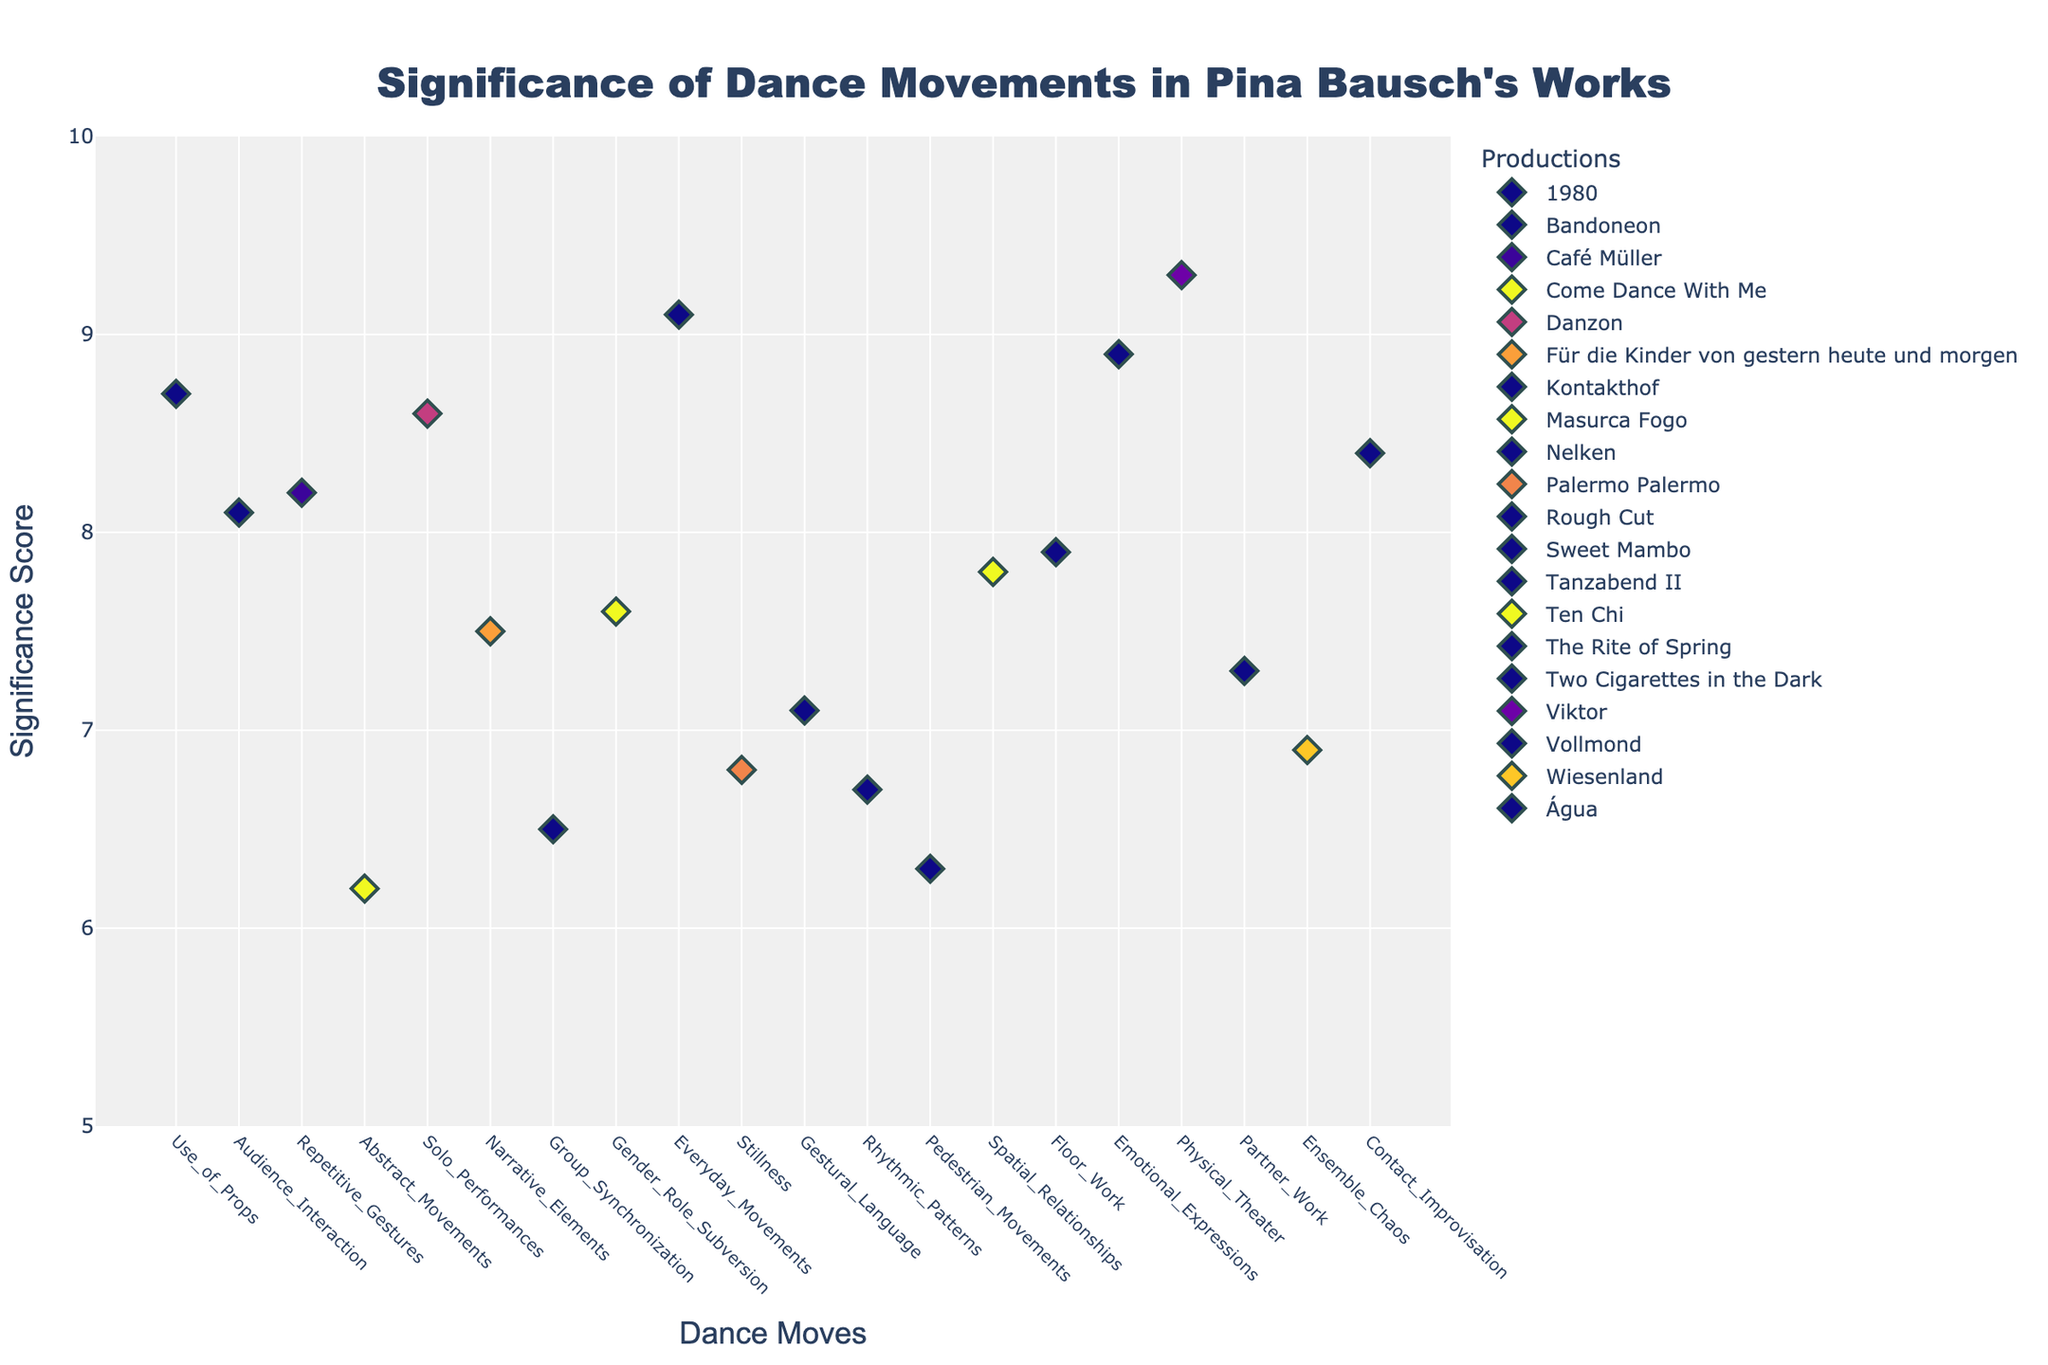What is the title of the figure? The title of the figure is usually located at the top and stands out due to its larger and bold font size. Here, it is "Significance of Dance Movements in Pina Bausch's Works".
Answer: Significance of Dance Movements in Pina Bausch's Works What are the x and y axes labeled as? The x-axis is labeled as "Dance Moves", and the y-axis is labeled as "Significance Score". These labels clearly indicate the dimensions along which the data points are plotted.
Answer: Dance Moves, Significance Score Which dance move has the highest significance score, and what is that score? By observing the y-axis and identifying the highest marker on the plot, we see that "Physical Theater" has the highest significance score of 9.3 in the production "Viktor".
Answer: Physical Theater, 9.3 What is the significance score of "Everyday Movements" and which production is it associated with? Locate "Everyday Movements" on the x-axis and read off its y-value. It is associated with the "Nelken" production and has a significance score of 9.1.
Answer: 9.1, Nelken How many dance moves have a significance score of 8.0 or higher? Count the markers on the plot with y-values of 8.0 or higher. These include "Repetitive Gestures," "Everyday Movements," "Use of Props," "Emotional Expressions," "Contact Improvisation," "Solo Performances," "Audience Interaction," and "Physical Theater", totaling 8.
Answer: 8 Which production has the most number of dance moves scored, and how many does it have? Each unique production name is associated with dance moves on the x-axis. By counting the occurrences, it becomes clear that each production has only one associated dance move.
Answer: Each production has 1 dance move What dance move has the lowest significance score, and which production does it belong to? Find the lowest point on the y-axis and check the x-axis to identify the dance move and the hover text for the production. It’s "Abstract Movements" belonging to "Come Dance With Me" with a score of 6.2.
Answer: Abstract Movements, Come Dance With Me Does "Group Synchronization" in "Kontakthof" or "Partner Work" in "Vollmond" have a higher significance score? Compare the y-values of "Group Synchronization" and "Partner Work". "Partner Work" in "Vollmond" has a score of 7.3, higher than "Group Synchronization" in "Kontakthof", which has a score of 6.5.
Answer: Partner Work, 7.3 > 6.5 What is the average significance score of dance moves in "Água"? "Contact Improvisation" is the only dance move listed for "Água" with a significance score of 8.4, making the average 8.4.
Answer: 8.4 Which dance move has the closest score to 7.0, and what production is it from? Looking at the plot for scores around 7.0, "Gestural Language" in "Rough Cut" has a score of 7.1, which is the closest.
Answer: Gestural Language, Rough Cut 